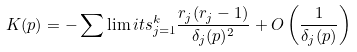Convert formula to latex. <formula><loc_0><loc_0><loc_500><loc_500>K ( p ) = - \sum \lim i t s _ { j = 1 } ^ { k } \frac { r _ { j } ( r _ { j } - 1 ) } { \delta _ { j } ( p ) ^ { 2 } } + O \left ( \frac { 1 } { \delta _ { j } ( p ) } \right )</formula> 